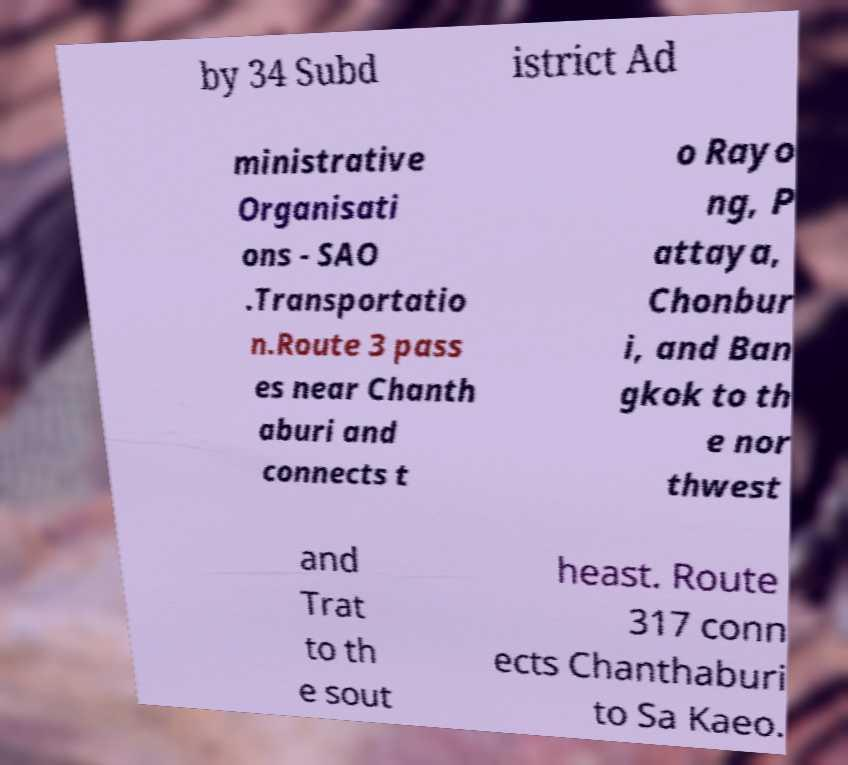There's text embedded in this image that I need extracted. Can you transcribe it verbatim? by 34 Subd istrict Ad ministrative Organisati ons - SAO .Transportatio n.Route 3 pass es near Chanth aburi and connects t o Rayo ng, P attaya, Chonbur i, and Ban gkok to th e nor thwest and Trat to th e sout heast. Route 317 conn ects Chanthaburi to Sa Kaeo. 